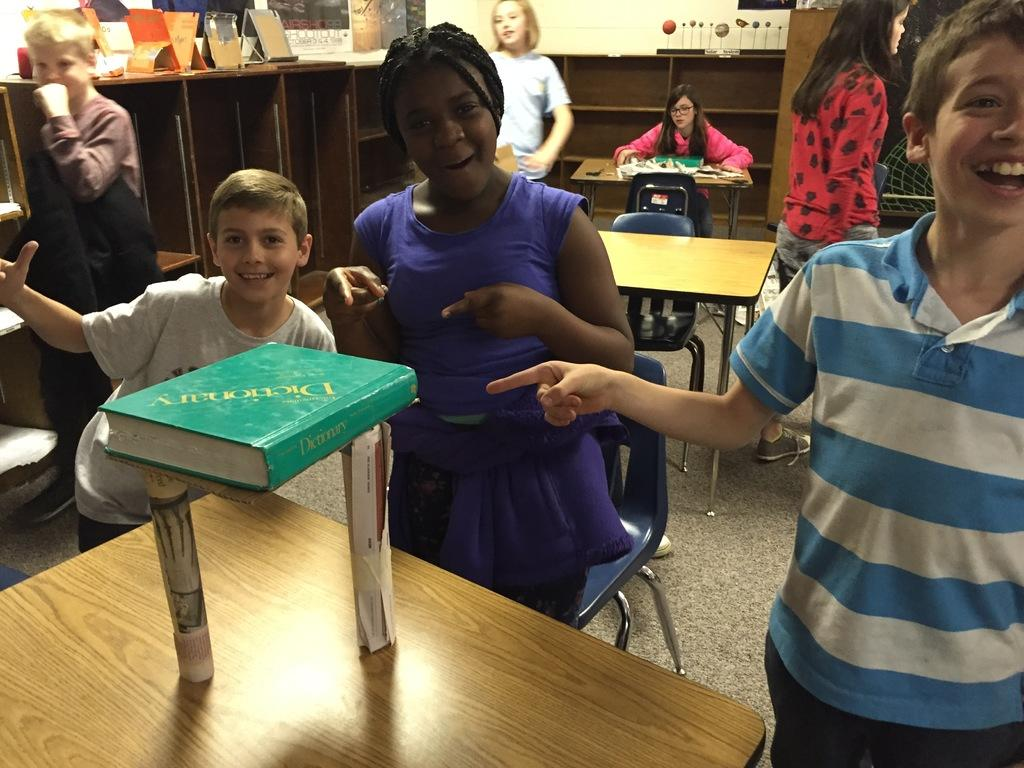Who is present in the image? There are children in the image. What are the children doing? The children are standing and laughing. What object is in front of the children? There is a book in front of the children. Is there anyone else in the image besides the children? Yes, there is a girl sitting in a chair behind the children. What type of pencil is the girl holding in the image? The girl is not holding a pencil in the image. 